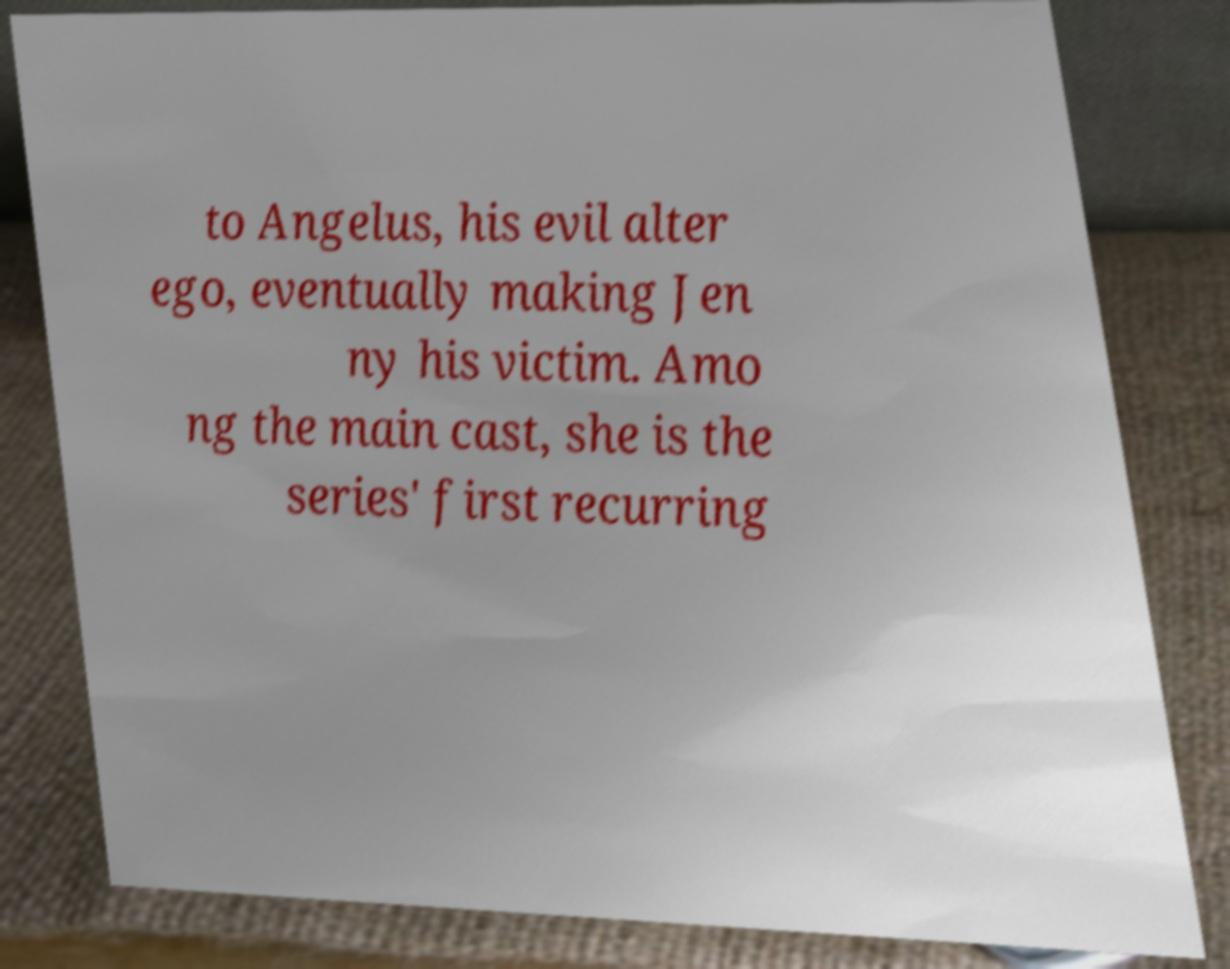Please read and relay the text visible in this image. What does it say? to Angelus, his evil alter ego, eventually making Jen ny his victim. Amo ng the main cast, she is the series' first recurring 